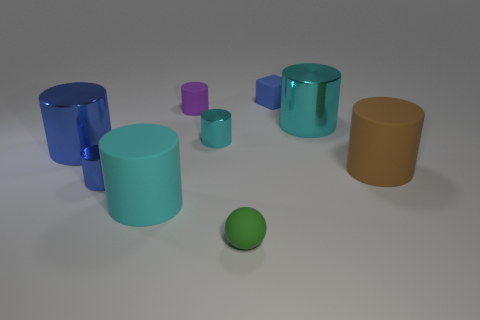What color is the small matte block? blue 